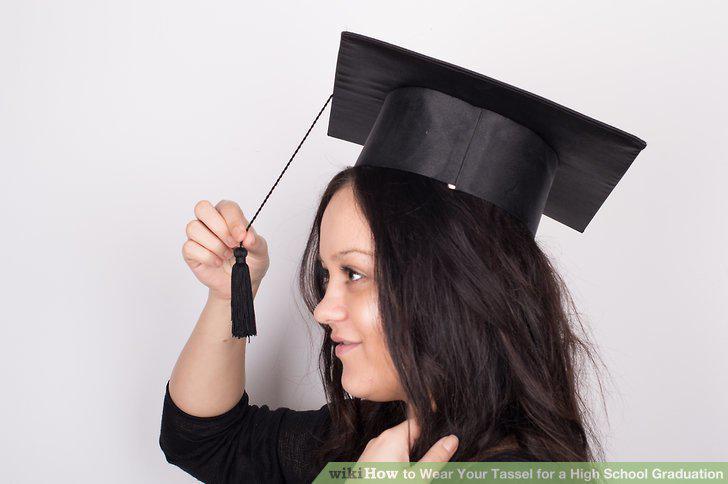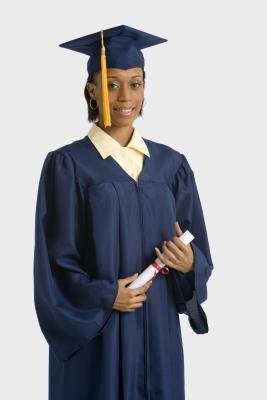The first image is the image on the left, the second image is the image on the right. Considering the images on both sides, is "One image shows a brunette female grasping the black tassel on her graduation cap." valid? Answer yes or no. Yes. The first image is the image on the left, the second image is the image on the right. Given the left and right images, does the statement "A mona is holding the tassel on her mortarboard." hold true? Answer yes or no. Yes. 